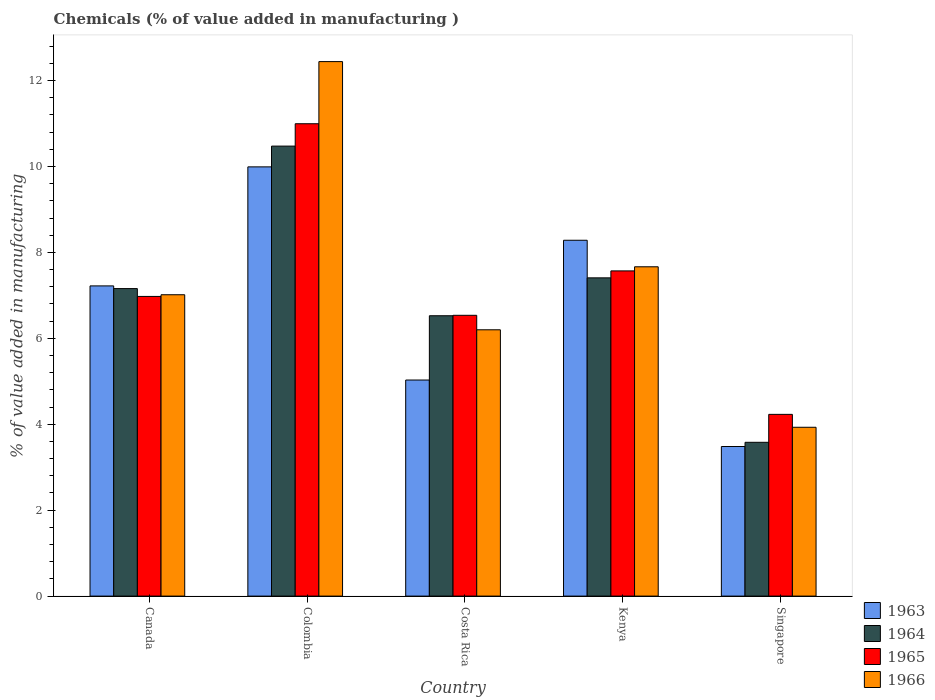How many different coloured bars are there?
Your answer should be very brief. 4. How many groups of bars are there?
Offer a very short reply. 5. How many bars are there on the 5th tick from the left?
Make the answer very short. 4. How many bars are there on the 4th tick from the right?
Your answer should be compact. 4. What is the label of the 1st group of bars from the left?
Give a very brief answer. Canada. What is the value added in manufacturing chemicals in 1964 in Costa Rica?
Provide a short and direct response. 6.53. Across all countries, what is the maximum value added in manufacturing chemicals in 1965?
Provide a succinct answer. 10.99. Across all countries, what is the minimum value added in manufacturing chemicals in 1965?
Make the answer very short. 4.23. In which country was the value added in manufacturing chemicals in 1966 maximum?
Keep it short and to the point. Colombia. In which country was the value added in manufacturing chemicals in 1964 minimum?
Offer a very short reply. Singapore. What is the total value added in manufacturing chemicals in 1964 in the graph?
Ensure brevity in your answer.  35.15. What is the difference between the value added in manufacturing chemicals in 1963 in Colombia and that in Kenya?
Give a very brief answer. 1.71. What is the difference between the value added in manufacturing chemicals in 1964 in Colombia and the value added in manufacturing chemicals in 1966 in Singapore?
Offer a terse response. 6.54. What is the average value added in manufacturing chemicals in 1964 per country?
Provide a succinct answer. 7.03. What is the difference between the value added in manufacturing chemicals of/in 1966 and value added in manufacturing chemicals of/in 1965 in Costa Rica?
Provide a succinct answer. -0.34. What is the ratio of the value added in manufacturing chemicals in 1964 in Canada to that in Colombia?
Offer a very short reply. 0.68. Is the value added in manufacturing chemicals in 1965 in Canada less than that in Singapore?
Give a very brief answer. No. What is the difference between the highest and the second highest value added in manufacturing chemicals in 1966?
Offer a very short reply. -5.43. What is the difference between the highest and the lowest value added in manufacturing chemicals in 1966?
Make the answer very short. 8.51. Is it the case that in every country, the sum of the value added in manufacturing chemicals in 1966 and value added in manufacturing chemicals in 1964 is greater than the sum of value added in manufacturing chemicals in 1965 and value added in manufacturing chemicals in 1963?
Ensure brevity in your answer.  No. What does the 2nd bar from the right in Canada represents?
Your answer should be compact. 1965. Is it the case that in every country, the sum of the value added in manufacturing chemicals in 1963 and value added in manufacturing chemicals in 1965 is greater than the value added in manufacturing chemicals in 1964?
Your answer should be very brief. Yes. Are all the bars in the graph horizontal?
Give a very brief answer. No. How many countries are there in the graph?
Provide a short and direct response. 5. What is the difference between two consecutive major ticks on the Y-axis?
Your answer should be very brief. 2. Are the values on the major ticks of Y-axis written in scientific E-notation?
Provide a succinct answer. No. Does the graph contain grids?
Your response must be concise. No. Where does the legend appear in the graph?
Your answer should be very brief. Bottom right. What is the title of the graph?
Offer a terse response. Chemicals (% of value added in manufacturing ). What is the label or title of the Y-axis?
Offer a very short reply. % of value added in manufacturing. What is the % of value added in manufacturing in 1963 in Canada?
Ensure brevity in your answer.  7.22. What is the % of value added in manufacturing in 1964 in Canada?
Ensure brevity in your answer.  7.16. What is the % of value added in manufacturing in 1965 in Canada?
Your answer should be compact. 6.98. What is the % of value added in manufacturing in 1966 in Canada?
Provide a succinct answer. 7.01. What is the % of value added in manufacturing in 1963 in Colombia?
Make the answer very short. 9.99. What is the % of value added in manufacturing in 1964 in Colombia?
Offer a very short reply. 10.47. What is the % of value added in manufacturing in 1965 in Colombia?
Your response must be concise. 10.99. What is the % of value added in manufacturing in 1966 in Colombia?
Offer a terse response. 12.44. What is the % of value added in manufacturing of 1963 in Costa Rica?
Offer a very short reply. 5.03. What is the % of value added in manufacturing in 1964 in Costa Rica?
Make the answer very short. 6.53. What is the % of value added in manufacturing of 1965 in Costa Rica?
Give a very brief answer. 6.54. What is the % of value added in manufacturing in 1966 in Costa Rica?
Make the answer very short. 6.2. What is the % of value added in manufacturing of 1963 in Kenya?
Provide a short and direct response. 8.28. What is the % of value added in manufacturing of 1964 in Kenya?
Your response must be concise. 7.41. What is the % of value added in manufacturing in 1965 in Kenya?
Offer a terse response. 7.57. What is the % of value added in manufacturing in 1966 in Kenya?
Keep it short and to the point. 7.67. What is the % of value added in manufacturing in 1963 in Singapore?
Keep it short and to the point. 3.48. What is the % of value added in manufacturing of 1964 in Singapore?
Provide a short and direct response. 3.58. What is the % of value added in manufacturing of 1965 in Singapore?
Your response must be concise. 4.23. What is the % of value added in manufacturing in 1966 in Singapore?
Provide a short and direct response. 3.93. Across all countries, what is the maximum % of value added in manufacturing in 1963?
Your answer should be very brief. 9.99. Across all countries, what is the maximum % of value added in manufacturing in 1964?
Offer a very short reply. 10.47. Across all countries, what is the maximum % of value added in manufacturing in 1965?
Provide a succinct answer. 10.99. Across all countries, what is the maximum % of value added in manufacturing of 1966?
Offer a very short reply. 12.44. Across all countries, what is the minimum % of value added in manufacturing of 1963?
Provide a short and direct response. 3.48. Across all countries, what is the minimum % of value added in manufacturing in 1964?
Your answer should be very brief. 3.58. Across all countries, what is the minimum % of value added in manufacturing of 1965?
Your answer should be compact. 4.23. Across all countries, what is the minimum % of value added in manufacturing in 1966?
Offer a terse response. 3.93. What is the total % of value added in manufacturing in 1963 in the graph?
Offer a very short reply. 34.01. What is the total % of value added in manufacturing in 1964 in the graph?
Provide a succinct answer. 35.15. What is the total % of value added in manufacturing in 1965 in the graph?
Offer a very short reply. 36.31. What is the total % of value added in manufacturing in 1966 in the graph?
Offer a terse response. 37.25. What is the difference between the % of value added in manufacturing in 1963 in Canada and that in Colombia?
Give a very brief answer. -2.77. What is the difference between the % of value added in manufacturing of 1964 in Canada and that in Colombia?
Your answer should be very brief. -3.32. What is the difference between the % of value added in manufacturing of 1965 in Canada and that in Colombia?
Give a very brief answer. -4.02. What is the difference between the % of value added in manufacturing of 1966 in Canada and that in Colombia?
Offer a very short reply. -5.43. What is the difference between the % of value added in manufacturing in 1963 in Canada and that in Costa Rica?
Keep it short and to the point. 2.19. What is the difference between the % of value added in manufacturing in 1964 in Canada and that in Costa Rica?
Your answer should be compact. 0.63. What is the difference between the % of value added in manufacturing in 1965 in Canada and that in Costa Rica?
Your response must be concise. 0.44. What is the difference between the % of value added in manufacturing in 1966 in Canada and that in Costa Rica?
Give a very brief answer. 0.82. What is the difference between the % of value added in manufacturing of 1963 in Canada and that in Kenya?
Your response must be concise. -1.06. What is the difference between the % of value added in manufacturing in 1964 in Canada and that in Kenya?
Your response must be concise. -0.25. What is the difference between the % of value added in manufacturing of 1965 in Canada and that in Kenya?
Offer a terse response. -0.59. What is the difference between the % of value added in manufacturing in 1966 in Canada and that in Kenya?
Ensure brevity in your answer.  -0.65. What is the difference between the % of value added in manufacturing in 1963 in Canada and that in Singapore?
Give a very brief answer. 3.74. What is the difference between the % of value added in manufacturing of 1964 in Canada and that in Singapore?
Keep it short and to the point. 3.58. What is the difference between the % of value added in manufacturing of 1965 in Canada and that in Singapore?
Keep it short and to the point. 2.75. What is the difference between the % of value added in manufacturing of 1966 in Canada and that in Singapore?
Give a very brief answer. 3.08. What is the difference between the % of value added in manufacturing in 1963 in Colombia and that in Costa Rica?
Offer a terse response. 4.96. What is the difference between the % of value added in manufacturing in 1964 in Colombia and that in Costa Rica?
Ensure brevity in your answer.  3.95. What is the difference between the % of value added in manufacturing in 1965 in Colombia and that in Costa Rica?
Offer a terse response. 4.46. What is the difference between the % of value added in manufacturing in 1966 in Colombia and that in Costa Rica?
Your answer should be compact. 6.24. What is the difference between the % of value added in manufacturing in 1963 in Colombia and that in Kenya?
Offer a very short reply. 1.71. What is the difference between the % of value added in manufacturing in 1964 in Colombia and that in Kenya?
Your response must be concise. 3.07. What is the difference between the % of value added in manufacturing in 1965 in Colombia and that in Kenya?
Make the answer very short. 3.43. What is the difference between the % of value added in manufacturing of 1966 in Colombia and that in Kenya?
Offer a very short reply. 4.78. What is the difference between the % of value added in manufacturing in 1963 in Colombia and that in Singapore?
Give a very brief answer. 6.51. What is the difference between the % of value added in manufacturing in 1964 in Colombia and that in Singapore?
Make the answer very short. 6.89. What is the difference between the % of value added in manufacturing of 1965 in Colombia and that in Singapore?
Ensure brevity in your answer.  6.76. What is the difference between the % of value added in manufacturing in 1966 in Colombia and that in Singapore?
Your response must be concise. 8.51. What is the difference between the % of value added in manufacturing of 1963 in Costa Rica and that in Kenya?
Give a very brief answer. -3.25. What is the difference between the % of value added in manufacturing in 1964 in Costa Rica and that in Kenya?
Give a very brief answer. -0.88. What is the difference between the % of value added in manufacturing of 1965 in Costa Rica and that in Kenya?
Offer a terse response. -1.03. What is the difference between the % of value added in manufacturing of 1966 in Costa Rica and that in Kenya?
Make the answer very short. -1.47. What is the difference between the % of value added in manufacturing in 1963 in Costa Rica and that in Singapore?
Provide a short and direct response. 1.55. What is the difference between the % of value added in manufacturing in 1964 in Costa Rica and that in Singapore?
Your answer should be very brief. 2.95. What is the difference between the % of value added in manufacturing in 1965 in Costa Rica and that in Singapore?
Your answer should be very brief. 2.31. What is the difference between the % of value added in manufacturing of 1966 in Costa Rica and that in Singapore?
Your response must be concise. 2.27. What is the difference between the % of value added in manufacturing of 1963 in Kenya and that in Singapore?
Give a very brief answer. 4.8. What is the difference between the % of value added in manufacturing in 1964 in Kenya and that in Singapore?
Provide a short and direct response. 3.83. What is the difference between the % of value added in manufacturing of 1965 in Kenya and that in Singapore?
Provide a short and direct response. 3.34. What is the difference between the % of value added in manufacturing of 1966 in Kenya and that in Singapore?
Keep it short and to the point. 3.74. What is the difference between the % of value added in manufacturing of 1963 in Canada and the % of value added in manufacturing of 1964 in Colombia?
Your answer should be very brief. -3.25. What is the difference between the % of value added in manufacturing of 1963 in Canada and the % of value added in manufacturing of 1965 in Colombia?
Provide a short and direct response. -3.77. What is the difference between the % of value added in manufacturing of 1963 in Canada and the % of value added in manufacturing of 1966 in Colombia?
Offer a very short reply. -5.22. What is the difference between the % of value added in manufacturing in 1964 in Canada and the % of value added in manufacturing in 1965 in Colombia?
Offer a very short reply. -3.84. What is the difference between the % of value added in manufacturing in 1964 in Canada and the % of value added in manufacturing in 1966 in Colombia?
Offer a terse response. -5.28. What is the difference between the % of value added in manufacturing in 1965 in Canada and the % of value added in manufacturing in 1966 in Colombia?
Provide a succinct answer. -5.47. What is the difference between the % of value added in manufacturing in 1963 in Canada and the % of value added in manufacturing in 1964 in Costa Rica?
Ensure brevity in your answer.  0.69. What is the difference between the % of value added in manufacturing in 1963 in Canada and the % of value added in manufacturing in 1965 in Costa Rica?
Your answer should be compact. 0.68. What is the difference between the % of value added in manufacturing in 1963 in Canada and the % of value added in manufacturing in 1966 in Costa Rica?
Make the answer very short. 1.02. What is the difference between the % of value added in manufacturing of 1964 in Canada and the % of value added in manufacturing of 1965 in Costa Rica?
Your response must be concise. 0.62. What is the difference between the % of value added in manufacturing of 1964 in Canada and the % of value added in manufacturing of 1966 in Costa Rica?
Your answer should be very brief. 0.96. What is the difference between the % of value added in manufacturing in 1965 in Canada and the % of value added in manufacturing in 1966 in Costa Rica?
Make the answer very short. 0.78. What is the difference between the % of value added in manufacturing of 1963 in Canada and the % of value added in manufacturing of 1964 in Kenya?
Provide a succinct answer. -0.19. What is the difference between the % of value added in manufacturing in 1963 in Canada and the % of value added in manufacturing in 1965 in Kenya?
Your answer should be very brief. -0.35. What is the difference between the % of value added in manufacturing in 1963 in Canada and the % of value added in manufacturing in 1966 in Kenya?
Offer a terse response. -0.44. What is the difference between the % of value added in manufacturing in 1964 in Canada and the % of value added in manufacturing in 1965 in Kenya?
Give a very brief answer. -0.41. What is the difference between the % of value added in manufacturing of 1964 in Canada and the % of value added in manufacturing of 1966 in Kenya?
Provide a succinct answer. -0.51. What is the difference between the % of value added in manufacturing in 1965 in Canada and the % of value added in manufacturing in 1966 in Kenya?
Your answer should be compact. -0.69. What is the difference between the % of value added in manufacturing in 1963 in Canada and the % of value added in manufacturing in 1964 in Singapore?
Make the answer very short. 3.64. What is the difference between the % of value added in manufacturing in 1963 in Canada and the % of value added in manufacturing in 1965 in Singapore?
Provide a short and direct response. 2.99. What is the difference between the % of value added in manufacturing in 1963 in Canada and the % of value added in manufacturing in 1966 in Singapore?
Ensure brevity in your answer.  3.29. What is the difference between the % of value added in manufacturing in 1964 in Canada and the % of value added in manufacturing in 1965 in Singapore?
Provide a short and direct response. 2.93. What is the difference between the % of value added in manufacturing of 1964 in Canada and the % of value added in manufacturing of 1966 in Singapore?
Offer a very short reply. 3.23. What is the difference between the % of value added in manufacturing of 1965 in Canada and the % of value added in manufacturing of 1966 in Singapore?
Your answer should be very brief. 3.05. What is the difference between the % of value added in manufacturing of 1963 in Colombia and the % of value added in manufacturing of 1964 in Costa Rica?
Keep it short and to the point. 3.47. What is the difference between the % of value added in manufacturing of 1963 in Colombia and the % of value added in manufacturing of 1965 in Costa Rica?
Give a very brief answer. 3.46. What is the difference between the % of value added in manufacturing of 1963 in Colombia and the % of value added in manufacturing of 1966 in Costa Rica?
Ensure brevity in your answer.  3.79. What is the difference between the % of value added in manufacturing of 1964 in Colombia and the % of value added in manufacturing of 1965 in Costa Rica?
Keep it short and to the point. 3.94. What is the difference between the % of value added in manufacturing of 1964 in Colombia and the % of value added in manufacturing of 1966 in Costa Rica?
Give a very brief answer. 4.28. What is the difference between the % of value added in manufacturing of 1965 in Colombia and the % of value added in manufacturing of 1966 in Costa Rica?
Ensure brevity in your answer.  4.8. What is the difference between the % of value added in manufacturing in 1963 in Colombia and the % of value added in manufacturing in 1964 in Kenya?
Your response must be concise. 2.58. What is the difference between the % of value added in manufacturing in 1963 in Colombia and the % of value added in manufacturing in 1965 in Kenya?
Provide a short and direct response. 2.42. What is the difference between the % of value added in manufacturing of 1963 in Colombia and the % of value added in manufacturing of 1966 in Kenya?
Your response must be concise. 2.33. What is the difference between the % of value added in manufacturing in 1964 in Colombia and the % of value added in manufacturing in 1965 in Kenya?
Provide a short and direct response. 2.9. What is the difference between the % of value added in manufacturing in 1964 in Colombia and the % of value added in manufacturing in 1966 in Kenya?
Make the answer very short. 2.81. What is the difference between the % of value added in manufacturing in 1965 in Colombia and the % of value added in manufacturing in 1966 in Kenya?
Ensure brevity in your answer.  3.33. What is the difference between the % of value added in manufacturing of 1963 in Colombia and the % of value added in manufacturing of 1964 in Singapore?
Provide a short and direct response. 6.41. What is the difference between the % of value added in manufacturing of 1963 in Colombia and the % of value added in manufacturing of 1965 in Singapore?
Keep it short and to the point. 5.76. What is the difference between the % of value added in manufacturing of 1963 in Colombia and the % of value added in manufacturing of 1966 in Singapore?
Your answer should be very brief. 6.06. What is the difference between the % of value added in manufacturing of 1964 in Colombia and the % of value added in manufacturing of 1965 in Singapore?
Ensure brevity in your answer.  6.24. What is the difference between the % of value added in manufacturing in 1964 in Colombia and the % of value added in manufacturing in 1966 in Singapore?
Provide a short and direct response. 6.54. What is the difference between the % of value added in manufacturing in 1965 in Colombia and the % of value added in manufacturing in 1966 in Singapore?
Your answer should be compact. 7.07. What is the difference between the % of value added in manufacturing of 1963 in Costa Rica and the % of value added in manufacturing of 1964 in Kenya?
Provide a succinct answer. -2.38. What is the difference between the % of value added in manufacturing in 1963 in Costa Rica and the % of value added in manufacturing in 1965 in Kenya?
Make the answer very short. -2.54. What is the difference between the % of value added in manufacturing of 1963 in Costa Rica and the % of value added in manufacturing of 1966 in Kenya?
Offer a very short reply. -2.64. What is the difference between the % of value added in manufacturing in 1964 in Costa Rica and the % of value added in manufacturing in 1965 in Kenya?
Your answer should be very brief. -1.04. What is the difference between the % of value added in manufacturing of 1964 in Costa Rica and the % of value added in manufacturing of 1966 in Kenya?
Make the answer very short. -1.14. What is the difference between the % of value added in manufacturing in 1965 in Costa Rica and the % of value added in manufacturing in 1966 in Kenya?
Offer a very short reply. -1.13. What is the difference between the % of value added in manufacturing of 1963 in Costa Rica and the % of value added in manufacturing of 1964 in Singapore?
Ensure brevity in your answer.  1.45. What is the difference between the % of value added in manufacturing in 1963 in Costa Rica and the % of value added in manufacturing in 1965 in Singapore?
Ensure brevity in your answer.  0.8. What is the difference between the % of value added in manufacturing in 1963 in Costa Rica and the % of value added in manufacturing in 1966 in Singapore?
Your answer should be very brief. 1.1. What is the difference between the % of value added in manufacturing of 1964 in Costa Rica and the % of value added in manufacturing of 1965 in Singapore?
Provide a short and direct response. 2.3. What is the difference between the % of value added in manufacturing of 1964 in Costa Rica and the % of value added in manufacturing of 1966 in Singapore?
Your response must be concise. 2.6. What is the difference between the % of value added in manufacturing in 1965 in Costa Rica and the % of value added in manufacturing in 1966 in Singapore?
Your response must be concise. 2.61. What is the difference between the % of value added in manufacturing in 1963 in Kenya and the % of value added in manufacturing in 1964 in Singapore?
Provide a short and direct response. 4.7. What is the difference between the % of value added in manufacturing in 1963 in Kenya and the % of value added in manufacturing in 1965 in Singapore?
Offer a terse response. 4.05. What is the difference between the % of value added in manufacturing in 1963 in Kenya and the % of value added in manufacturing in 1966 in Singapore?
Provide a succinct answer. 4.35. What is the difference between the % of value added in manufacturing of 1964 in Kenya and the % of value added in manufacturing of 1965 in Singapore?
Your answer should be compact. 3.18. What is the difference between the % of value added in manufacturing in 1964 in Kenya and the % of value added in manufacturing in 1966 in Singapore?
Offer a terse response. 3.48. What is the difference between the % of value added in manufacturing of 1965 in Kenya and the % of value added in manufacturing of 1966 in Singapore?
Offer a terse response. 3.64. What is the average % of value added in manufacturing in 1963 per country?
Give a very brief answer. 6.8. What is the average % of value added in manufacturing of 1964 per country?
Your answer should be very brief. 7.03. What is the average % of value added in manufacturing in 1965 per country?
Your answer should be compact. 7.26. What is the average % of value added in manufacturing in 1966 per country?
Make the answer very short. 7.45. What is the difference between the % of value added in manufacturing of 1963 and % of value added in manufacturing of 1964 in Canada?
Make the answer very short. 0.06. What is the difference between the % of value added in manufacturing of 1963 and % of value added in manufacturing of 1965 in Canada?
Ensure brevity in your answer.  0.25. What is the difference between the % of value added in manufacturing of 1963 and % of value added in manufacturing of 1966 in Canada?
Your answer should be very brief. 0.21. What is the difference between the % of value added in manufacturing of 1964 and % of value added in manufacturing of 1965 in Canada?
Make the answer very short. 0.18. What is the difference between the % of value added in manufacturing in 1964 and % of value added in manufacturing in 1966 in Canada?
Your answer should be very brief. 0.14. What is the difference between the % of value added in manufacturing in 1965 and % of value added in manufacturing in 1966 in Canada?
Offer a very short reply. -0.04. What is the difference between the % of value added in manufacturing of 1963 and % of value added in manufacturing of 1964 in Colombia?
Offer a terse response. -0.48. What is the difference between the % of value added in manufacturing of 1963 and % of value added in manufacturing of 1965 in Colombia?
Provide a short and direct response. -1. What is the difference between the % of value added in manufacturing in 1963 and % of value added in manufacturing in 1966 in Colombia?
Ensure brevity in your answer.  -2.45. What is the difference between the % of value added in manufacturing in 1964 and % of value added in manufacturing in 1965 in Colombia?
Your response must be concise. -0.52. What is the difference between the % of value added in manufacturing of 1964 and % of value added in manufacturing of 1966 in Colombia?
Keep it short and to the point. -1.97. What is the difference between the % of value added in manufacturing of 1965 and % of value added in manufacturing of 1966 in Colombia?
Make the answer very short. -1.45. What is the difference between the % of value added in manufacturing of 1963 and % of value added in manufacturing of 1964 in Costa Rica?
Give a very brief answer. -1.5. What is the difference between the % of value added in manufacturing in 1963 and % of value added in manufacturing in 1965 in Costa Rica?
Your answer should be compact. -1.51. What is the difference between the % of value added in manufacturing of 1963 and % of value added in manufacturing of 1966 in Costa Rica?
Offer a very short reply. -1.17. What is the difference between the % of value added in manufacturing in 1964 and % of value added in manufacturing in 1965 in Costa Rica?
Offer a terse response. -0.01. What is the difference between the % of value added in manufacturing of 1964 and % of value added in manufacturing of 1966 in Costa Rica?
Make the answer very short. 0.33. What is the difference between the % of value added in manufacturing of 1965 and % of value added in manufacturing of 1966 in Costa Rica?
Keep it short and to the point. 0.34. What is the difference between the % of value added in manufacturing of 1963 and % of value added in manufacturing of 1964 in Kenya?
Offer a very short reply. 0.87. What is the difference between the % of value added in manufacturing of 1963 and % of value added in manufacturing of 1965 in Kenya?
Your answer should be compact. 0.71. What is the difference between the % of value added in manufacturing in 1963 and % of value added in manufacturing in 1966 in Kenya?
Keep it short and to the point. 0.62. What is the difference between the % of value added in manufacturing of 1964 and % of value added in manufacturing of 1965 in Kenya?
Keep it short and to the point. -0.16. What is the difference between the % of value added in manufacturing of 1964 and % of value added in manufacturing of 1966 in Kenya?
Your answer should be very brief. -0.26. What is the difference between the % of value added in manufacturing in 1965 and % of value added in manufacturing in 1966 in Kenya?
Give a very brief answer. -0.1. What is the difference between the % of value added in manufacturing of 1963 and % of value added in manufacturing of 1964 in Singapore?
Your answer should be very brief. -0.1. What is the difference between the % of value added in manufacturing of 1963 and % of value added in manufacturing of 1965 in Singapore?
Your answer should be very brief. -0.75. What is the difference between the % of value added in manufacturing of 1963 and % of value added in manufacturing of 1966 in Singapore?
Your answer should be very brief. -0.45. What is the difference between the % of value added in manufacturing in 1964 and % of value added in manufacturing in 1965 in Singapore?
Provide a short and direct response. -0.65. What is the difference between the % of value added in manufacturing of 1964 and % of value added in manufacturing of 1966 in Singapore?
Your response must be concise. -0.35. What is the difference between the % of value added in manufacturing in 1965 and % of value added in manufacturing in 1966 in Singapore?
Provide a short and direct response. 0.3. What is the ratio of the % of value added in manufacturing in 1963 in Canada to that in Colombia?
Keep it short and to the point. 0.72. What is the ratio of the % of value added in manufacturing in 1964 in Canada to that in Colombia?
Keep it short and to the point. 0.68. What is the ratio of the % of value added in manufacturing in 1965 in Canada to that in Colombia?
Give a very brief answer. 0.63. What is the ratio of the % of value added in manufacturing of 1966 in Canada to that in Colombia?
Your answer should be very brief. 0.56. What is the ratio of the % of value added in manufacturing in 1963 in Canada to that in Costa Rica?
Keep it short and to the point. 1.44. What is the ratio of the % of value added in manufacturing of 1964 in Canada to that in Costa Rica?
Make the answer very short. 1.1. What is the ratio of the % of value added in manufacturing of 1965 in Canada to that in Costa Rica?
Your response must be concise. 1.07. What is the ratio of the % of value added in manufacturing in 1966 in Canada to that in Costa Rica?
Ensure brevity in your answer.  1.13. What is the ratio of the % of value added in manufacturing in 1963 in Canada to that in Kenya?
Your response must be concise. 0.87. What is the ratio of the % of value added in manufacturing in 1964 in Canada to that in Kenya?
Give a very brief answer. 0.97. What is the ratio of the % of value added in manufacturing of 1965 in Canada to that in Kenya?
Make the answer very short. 0.92. What is the ratio of the % of value added in manufacturing in 1966 in Canada to that in Kenya?
Keep it short and to the point. 0.92. What is the ratio of the % of value added in manufacturing in 1963 in Canada to that in Singapore?
Give a very brief answer. 2.07. What is the ratio of the % of value added in manufacturing of 1964 in Canada to that in Singapore?
Your response must be concise. 2. What is the ratio of the % of value added in manufacturing of 1965 in Canada to that in Singapore?
Ensure brevity in your answer.  1.65. What is the ratio of the % of value added in manufacturing in 1966 in Canada to that in Singapore?
Make the answer very short. 1.78. What is the ratio of the % of value added in manufacturing of 1963 in Colombia to that in Costa Rica?
Your answer should be compact. 1.99. What is the ratio of the % of value added in manufacturing of 1964 in Colombia to that in Costa Rica?
Your answer should be very brief. 1.61. What is the ratio of the % of value added in manufacturing in 1965 in Colombia to that in Costa Rica?
Your response must be concise. 1.68. What is the ratio of the % of value added in manufacturing in 1966 in Colombia to that in Costa Rica?
Give a very brief answer. 2.01. What is the ratio of the % of value added in manufacturing of 1963 in Colombia to that in Kenya?
Provide a succinct answer. 1.21. What is the ratio of the % of value added in manufacturing in 1964 in Colombia to that in Kenya?
Make the answer very short. 1.41. What is the ratio of the % of value added in manufacturing of 1965 in Colombia to that in Kenya?
Ensure brevity in your answer.  1.45. What is the ratio of the % of value added in manufacturing in 1966 in Colombia to that in Kenya?
Make the answer very short. 1.62. What is the ratio of the % of value added in manufacturing of 1963 in Colombia to that in Singapore?
Provide a short and direct response. 2.87. What is the ratio of the % of value added in manufacturing of 1964 in Colombia to that in Singapore?
Provide a succinct answer. 2.93. What is the ratio of the % of value added in manufacturing of 1965 in Colombia to that in Singapore?
Your answer should be very brief. 2.6. What is the ratio of the % of value added in manufacturing of 1966 in Colombia to that in Singapore?
Your answer should be compact. 3.17. What is the ratio of the % of value added in manufacturing in 1963 in Costa Rica to that in Kenya?
Provide a short and direct response. 0.61. What is the ratio of the % of value added in manufacturing of 1964 in Costa Rica to that in Kenya?
Your answer should be compact. 0.88. What is the ratio of the % of value added in manufacturing of 1965 in Costa Rica to that in Kenya?
Offer a very short reply. 0.86. What is the ratio of the % of value added in manufacturing in 1966 in Costa Rica to that in Kenya?
Offer a very short reply. 0.81. What is the ratio of the % of value added in manufacturing of 1963 in Costa Rica to that in Singapore?
Your response must be concise. 1.44. What is the ratio of the % of value added in manufacturing of 1964 in Costa Rica to that in Singapore?
Ensure brevity in your answer.  1.82. What is the ratio of the % of value added in manufacturing in 1965 in Costa Rica to that in Singapore?
Your answer should be compact. 1.55. What is the ratio of the % of value added in manufacturing of 1966 in Costa Rica to that in Singapore?
Offer a terse response. 1.58. What is the ratio of the % of value added in manufacturing in 1963 in Kenya to that in Singapore?
Keep it short and to the point. 2.38. What is the ratio of the % of value added in manufacturing of 1964 in Kenya to that in Singapore?
Your answer should be very brief. 2.07. What is the ratio of the % of value added in manufacturing in 1965 in Kenya to that in Singapore?
Provide a short and direct response. 1.79. What is the ratio of the % of value added in manufacturing in 1966 in Kenya to that in Singapore?
Make the answer very short. 1.95. What is the difference between the highest and the second highest % of value added in manufacturing of 1963?
Make the answer very short. 1.71. What is the difference between the highest and the second highest % of value added in manufacturing of 1964?
Provide a short and direct response. 3.07. What is the difference between the highest and the second highest % of value added in manufacturing of 1965?
Keep it short and to the point. 3.43. What is the difference between the highest and the second highest % of value added in manufacturing of 1966?
Your answer should be very brief. 4.78. What is the difference between the highest and the lowest % of value added in manufacturing of 1963?
Your response must be concise. 6.51. What is the difference between the highest and the lowest % of value added in manufacturing of 1964?
Offer a terse response. 6.89. What is the difference between the highest and the lowest % of value added in manufacturing of 1965?
Offer a terse response. 6.76. What is the difference between the highest and the lowest % of value added in manufacturing in 1966?
Offer a terse response. 8.51. 